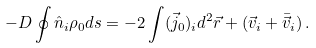<formula> <loc_0><loc_0><loc_500><loc_500>- D \oint \hat { n } _ { i } \rho _ { 0 } d s = - 2 \int ( \vec { j } _ { 0 } ) _ { i } d ^ { 2 } \vec { r } + ( \vec { v } _ { i } + \bar { \vec { v } } _ { i } ) \, .</formula> 